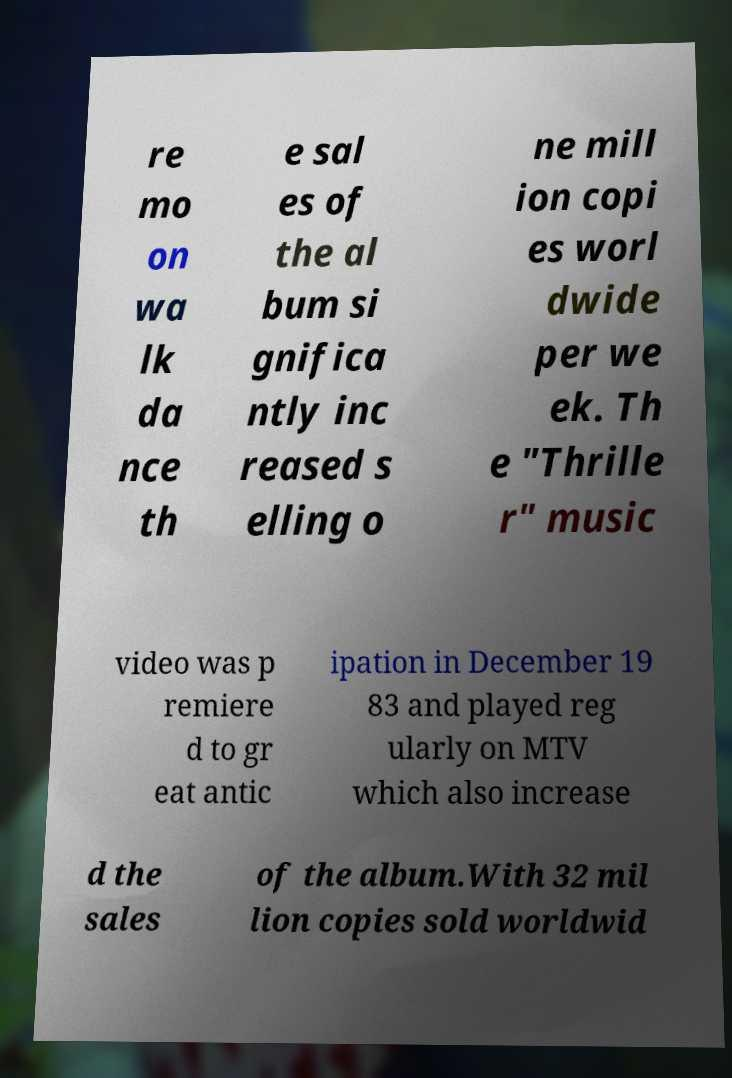Could you assist in decoding the text presented in this image and type it out clearly? re mo on wa lk da nce th e sal es of the al bum si gnifica ntly inc reased s elling o ne mill ion copi es worl dwide per we ek. Th e "Thrille r" music video was p remiere d to gr eat antic ipation in December 19 83 and played reg ularly on MTV which also increase d the sales of the album.With 32 mil lion copies sold worldwid 